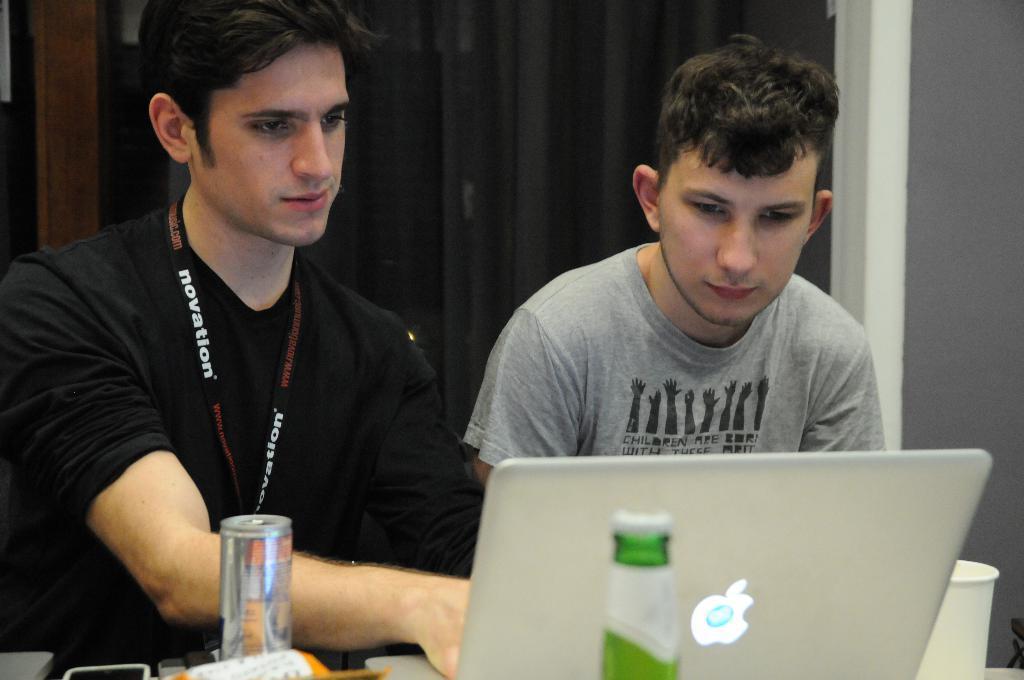How would you summarize this image in a sentence or two? In this image there are two persons sitting , and there is a bottle, glass, tin, laptop and some other items on the object , and in the background there is a wall. 